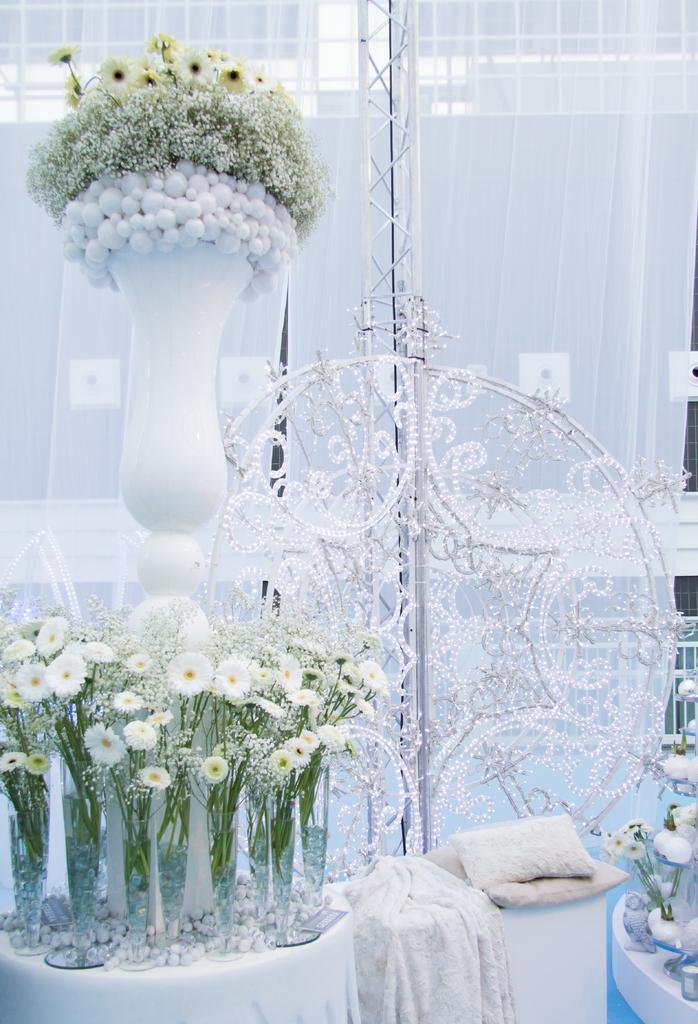In one or two sentences, can you explain what this image depicts? In this picture we can see a flower vase on the table, and at back here are the curtains. 